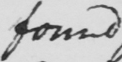What does this handwritten line say? found 